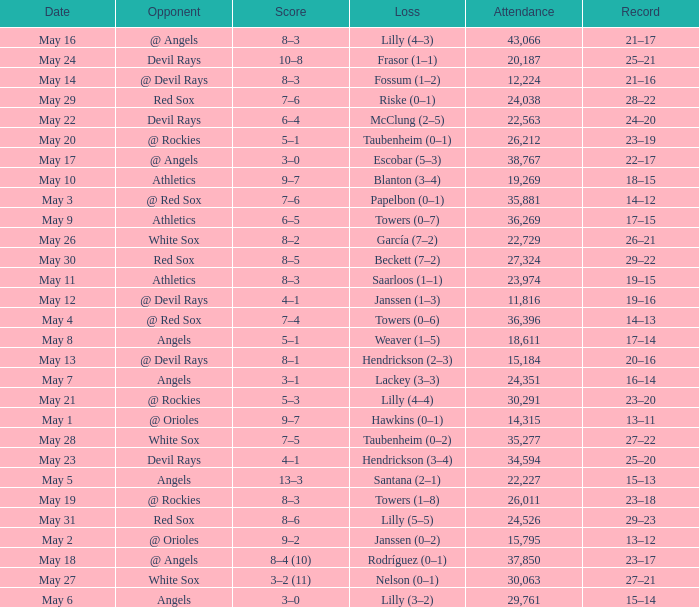When the team had their record of 16–14, what was the total attendance? 1.0. Can you give me this table as a dict? {'header': ['Date', 'Opponent', 'Score', 'Loss', 'Attendance', 'Record'], 'rows': [['May 16', '@ Angels', '8–3', 'Lilly (4–3)', '43,066', '21–17'], ['May 24', 'Devil Rays', '10–8', 'Frasor (1–1)', '20,187', '25–21'], ['May 14', '@ Devil Rays', '8–3', 'Fossum (1–2)', '12,224', '21–16'], ['May 29', 'Red Sox', '7–6', 'Riske (0–1)', '24,038', '28–22'], ['May 22', 'Devil Rays', '6–4', 'McClung (2–5)', '22,563', '24–20'], ['May 20', '@ Rockies', '5–1', 'Taubenheim (0–1)', '26,212', '23–19'], ['May 17', '@ Angels', '3–0', 'Escobar (5–3)', '38,767', '22–17'], ['May 10', 'Athletics', '9–7', 'Blanton (3–4)', '19,269', '18–15'], ['May 3', '@ Red Sox', '7–6', 'Papelbon (0–1)', '35,881', '14–12'], ['May 9', 'Athletics', '6–5', 'Towers (0–7)', '36,269', '17–15'], ['May 26', 'White Sox', '8–2', 'García (7–2)', '22,729', '26–21'], ['May 30', 'Red Sox', '8–5', 'Beckett (7–2)', '27,324', '29–22'], ['May 11', 'Athletics', '8–3', 'Saarloos (1–1)', '23,974', '19–15'], ['May 12', '@ Devil Rays', '4–1', 'Janssen (1–3)', '11,816', '19–16'], ['May 4', '@ Red Sox', '7–4', 'Towers (0–6)', '36,396', '14–13'], ['May 8', 'Angels', '5–1', 'Weaver (1–5)', '18,611', '17–14'], ['May 13', '@ Devil Rays', '8–1', 'Hendrickson (2–3)', '15,184', '20–16'], ['May 7', 'Angels', '3–1', 'Lackey (3–3)', '24,351', '16–14'], ['May 21', '@ Rockies', '5–3', 'Lilly (4–4)', '30,291', '23–20'], ['May 1', '@ Orioles', '9–7', 'Hawkins (0–1)', '14,315', '13–11'], ['May 28', 'White Sox', '7–5', 'Taubenheim (0–2)', '35,277', '27–22'], ['May 23', 'Devil Rays', '4–1', 'Hendrickson (3–4)', '34,594', '25–20'], ['May 5', 'Angels', '13–3', 'Santana (2–1)', '22,227', '15–13'], ['May 19', '@ Rockies', '8–3', 'Towers (1–8)', '26,011', '23–18'], ['May 31', 'Red Sox', '8–6', 'Lilly (5–5)', '24,526', '29–23'], ['May 2', '@ Orioles', '9–2', 'Janssen (0–2)', '15,795', '13–12'], ['May 18', '@ Angels', '8–4 (10)', 'Rodríguez (0–1)', '37,850', '23–17'], ['May 27', 'White Sox', '3–2 (11)', 'Nelson (0–1)', '30,063', '27–21'], ['May 6', 'Angels', '3–0', 'Lilly (3–2)', '29,761', '15–14']]} 